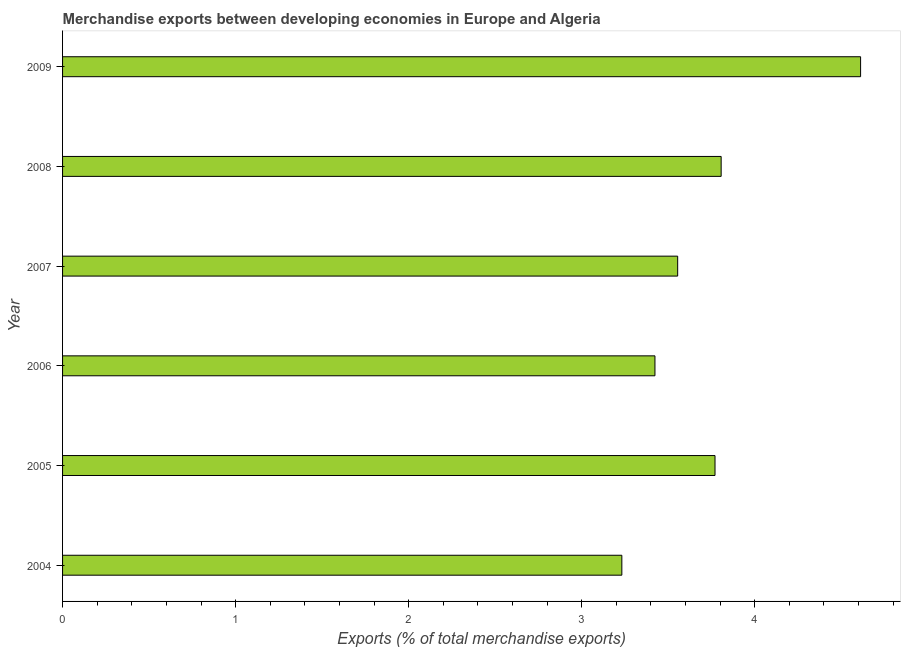Does the graph contain any zero values?
Offer a very short reply. No. What is the title of the graph?
Provide a short and direct response. Merchandise exports between developing economies in Europe and Algeria. What is the label or title of the X-axis?
Offer a terse response. Exports (% of total merchandise exports). What is the merchandise exports in 2005?
Ensure brevity in your answer.  3.77. Across all years, what is the maximum merchandise exports?
Provide a succinct answer. 4.61. Across all years, what is the minimum merchandise exports?
Your response must be concise. 3.23. In which year was the merchandise exports maximum?
Ensure brevity in your answer.  2009. What is the sum of the merchandise exports?
Offer a very short reply. 22.4. What is the difference between the merchandise exports in 2006 and 2008?
Keep it short and to the point. -0.38. What is the average merchandise exports per year?
Offer a terse response. 3.73. What is the median merchandise exports?
Ensure brevity in your answer.  3.66. In how many years, is the merchandise exports greater than 3.6 %?
Provide a succinct answer. 3. What is the ratio of the merchandise exports in 2005 to that in 2007?
Keep it short and to the point. 1.06. Is the difference between the merchandise exports in 2007 and 2008 greater than the difference between any two years?
Your response must be concise. No. What is the difference between the highest and the second highest merchandise exports?
Offer a very short reply. 0.81. Is the sum of the merchandise exports in 2005 and 2006 greater than the maximum merchandise exports across all years?
Provide a succinct answer. Yes. What is the difference between the highest and the lowest merchandise exports?
Provide a short and direct response. 1.38. In how many years, is the merchandise exports greater than the average merchandise exports taken over all years?
Provide a succinct answer. 3. What is the difference between two consecutive major ticks on the X-axis?
Give a very brief answer. 1. Are the values on the major ticks of X-axis written in scientific E-notation?
Offer a very short reply. No. What is the Exports (% of total merchandise exports) in 2004?
Your response must be concise. 3.23. What is the Exports (% of total merchandise exports) in 2005?
Ensure brevity in your answer.  3.77. What is the Exports (% of total merchandise exports) in 2006?
Offer a terse response. 3.42. What is the Exports (% of total merchandise exports) of 2007?
Your answer should be very brief. 3.55. What is the Exports (% of total merchandise exports) in 2008?
Offer a very short reply. 3.81. What is the Exports (% of total merchandise exports) in 2009?
Provide a short and direct response. 4.61. What is the difference between the Exports (% of total merchandise exports) in 2004 and 2005?
Offer a terse response. -0.54. What is the difference between the Exports (% of total merchandise exports) in 2004 and 2006?
Your answer should be very brief. -0.19. What is the difference between the Exports (% of total merchandise exports) in 2004 and 2007?
Give a very brief answer. -0.32. What is the difference between the Exports (% of total merchandise exports) in 2004 and 2008?
Make the answer very short. -0.57. What is the difference between the Exports (% of total merchandise exports) in 2004 and 2009?
Ensure brevity in your answer.  -1.38. What is the difference between the Exports (% of total merchandise exports) in 2005 and 2006?
Your answer should be compact. 0.35. What is the difference between the Exports (% of total merchandise exports) in 2005 and 2007?
Ensure brevity in your answer.  0.22. What is the difference between the Exports (% of total merchandise exports) in 2005 and 2008?
Your answer should be very brief. -0.04. What is the difference between the Exports (% of total merchandise exports) in 2005 and 2009?
Provide a short and direct response. -0.84. What is the difference between the Exports (% of total merchandise exports) in 2006 and 2007?
Your answer should be compact. -0.13. What is the difference between the Exports (% of total merchandise exports) in 2006 and 2008?
Keep it short and to the point. -0.38. What is the difference between the Exports (% of total merchandise exports) in 2006 and 2009?
Your answer should be very brief. -1.19. What is the difference between the Exports (% of total merchandise exports) in 2007 and 2008?
Your answer should be compact. -0.25. What is the difference between the Exports (% of total merchandise exports) in 2007 and 2009?
Make the answer very short. -1.06. What is the difference between the Exports (% of total merchandise exports) in 2008 and 2009?
Your answer should be very brief. -0.81. What is the ratio of the Exports (% of total merchandise exports) in 2004 to that in 2005?
Give a very brief answer. 0.86. What is the ratio of the Exports (% of total merchandise exports) in 2004 to that in 2006?
Offer a very short reply. 0.94. What is the ratio of the Exports (% of total merchandise exports) in 2004 to that in 2007?
Provide a succinct answer. 0.91. What is the ratio of the Exports (% of total merchandise exports) in 2004 to that in 2008?
Your answer should be compact. 0.85. What is the ratio of the Exports (% of total merchandise exports) in 2004 to that in 2009?
Your answer should be compact. 0.7. What is the ratio of the Exports (% of total merchandise exports) in 2005 to that in 2006?
Your answer should be very brief. 1.1. What is the ratio of the Exports (% of total merchandise exports) in 2005 to that in 2007?
Your answer should be very brief. 1.06. What is the ratio of the Exports (% of total merchandise exports) in 2005 to that in 2008?
Ensure brevity in your answer.  0.99. What is the ratio of the Exports (% of total merchandise exports) in 2005 to that in 2009?
Your answer should be very brief. 0.82. What is the ratio of the Exports (% of total merchandise exports) in 2006 to that in 2008?
Ensure brevity in your answer.  0.9. What is the ratio of the Exports (% of total merchandise exports) in 2006 to that in 2009?
Offer a terse response. 0.74. What is the ratio of the Exports (% of total merchandise exports) in 2007 to that in 2008?
Keep it short and to the point. 0.93. What is the ratio of the Exports (% of total merchandise exports) in 2007 to that in 2009?
Make the answer very short. 0.77. What is the ratio of the Exports (% of total merchandise exports) in 2008 to that in 2009?
Keep it short and to the point. 0.82. 